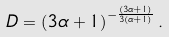<formula> <loc_0><loc_0><loc_500><loc_500>D = \left ( { 3 \alpha + 1 } \right ) ^ { - \frac { ( 3 \alpha + 1 ) } { 3 ( \alpha + 1 ) } } .</formula> 